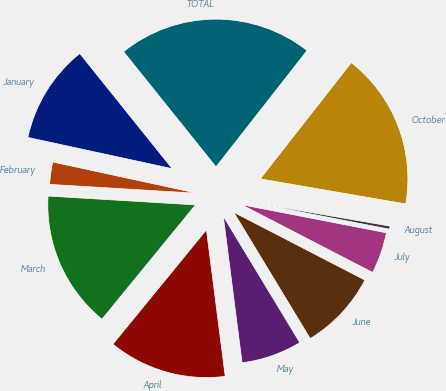<chart> <loc_0><loc_0><loc_500><loc_500><pie_chart><fcel>January<fcel>February<fcel>March<fcel>April<fcel>May<fcel>June<fcel>July<fcel>August<fcel>October<fcel>TOTAL<nl><fcel>10.84%<fcel>2.44%<fcel>15.04%<fcel>12.94%<fcel>6.64%<fcel>8.74%<fcel>4.54%<fcel>0.34%<fcel>17.14%<fcel>21.34%<nl></chart> 